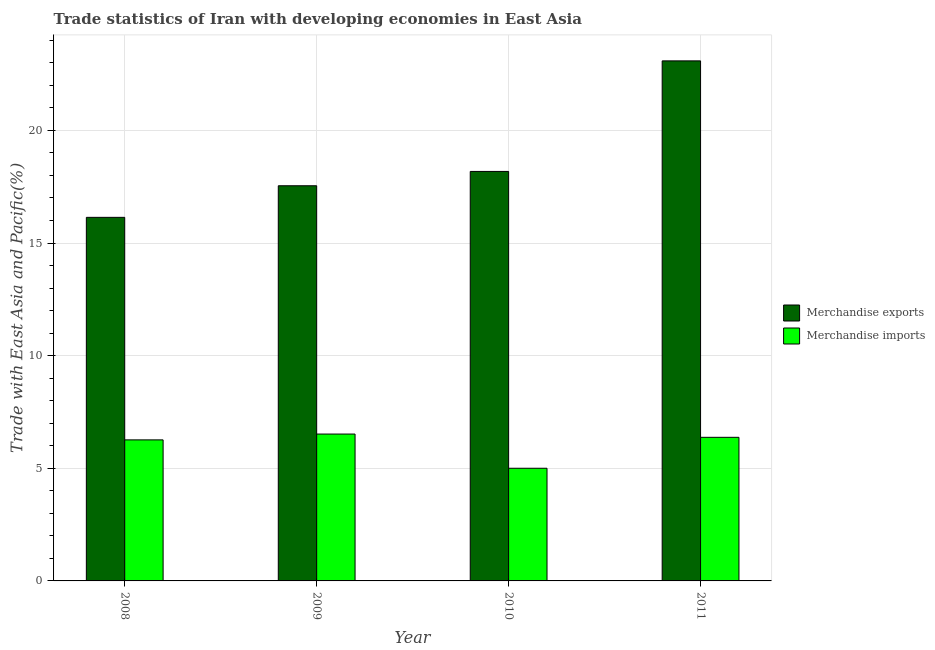Are the number of bars on each tick of the X-axis equal?
Offer a terse response. Yes. How many bars are there on the 1st tick from the left?
Keep it short and to the point. 2. In how many cases, is the number of bars for a given year not equal to the number of legend labels?
Offer a terse response. 0. What is the merchandise imports in 2009?
Offer a very short reply. 6.52. Across all years, what is the maximum merchandise exports?
Your answer should be compact. 23.09. Across all years, what is the minimum merchandise imports?
Provide a short and direct response. 5. In which year was the merchandise exports maximum?
Offer a very short reply. 2011. What is the total merchandise exports in the graph?
Offer a terse response. 74.94. What is the difference between the merchandise imports in 2009 and that in 2011?
Your answer should be very brief. 0.15. What is the difference between the merchandise exports in 2011 and the merchandise imports in 2009?
Your response must be concise. 5.54. What is the average merchandise imports per year?
Your answer should be compact. 6.04. In the year 2008, what is the difference between the merchandise exports and merchandise imports?
Offer a very short reply. 0. In how many years, is the merchandise exports greater than 2 %?
Provide a succinct answer. 4. What is the ratio of the merchandise imports in 2008 to that in 2009?
Make the answer very short. 0.96. What is the difference between the highest and the second highest merchandise imports?
Keep it short and to the point. 0.15. What is the difference between the highest and the lowest merchandise exports?
Your answer should be very brief. 6.95. Is the sum of the merchandise imports in 2010 and 2011 greater than the maximum merchandise exports across all years?
Ensure brevity in your answer.  Yes. What does the 2nd bar from the right in 2009 represents?
Provide a short and direct response. Merchandise exports. What is the difference between two consecutive major ticks on the Y-axis?
Your answer should be compact. 5. Are the values on the major ticks of Y-axis written in scientific E-notation?
Your answer should be compact. No. Where does the legend appear in the graph?
Offer a very short reply. Center right. How are the legend labels stacked?
Your answer should be compact. Vertical. What is the title of the graph?
Keep it short and to the point. Trade statistics of Iran with developing economies in East Asia. What is the label or title of the Y-axis?
Keep it short and to the point. Trade with East Asia and Pacific(%). What is the Trade with East Asia and Pacific(%) of Merchandise exports in 2008?
Make the answer very short. 16.14. What is the Trade with East Asia and Pacific(%) of Merchandise imports in 2008?
Your response must be concise. 6.26. What is the Trade with East Asia and Pacific(%) of Merchandise exports in 2009?
Give a very brief answer. 17.54. What is the Trade with East Asia and Pacific(%) of Merchandise imports in 2009?
Offer a very short reply. 6.52. What is the Trade with East Asia and Pacific(%) in Merchandise exports in 2010?
Your answer should be compact. 18.18. What is the Trade with East Asia and Pacific(%) of Merchandise imports in 2010?
Keep it short and to the point. 5. What is the Trade with East Asia and Pacific(%) of Merchandise exports in 2011?
Your answer should be compact. 23.09. What is the Trade with East Asia and Pacific(%) in Merchandise imports in 2011?
Provide a succinct answer. 6.37. Across all years, what is the maximum Trade with East Asia and Pacific(%) in Merchandise exports?
Give a very brief answer. 23.09. Across all years, what is the maximum Trade with East Asia and Pacific(%) in Merchandise imports?
Provide a succinct answer. 6.52. Across all years, what is the minimum Trade with East Asia and Pacific(%) in Merchandise exports?
Your answer should be very brief. 16.14. Across all years, what is the minimum Trade with East Asia and Pacific(%) of Merchandise imports?
Give a very brief answer. 5. What is the total Trade with East Asia and Pacific(%) of Merchandise exports in the graph?
Provide a succinct answer. 74.94. What is the total Trade with East Asia and Pacific(%) of Merchandise imports in the graph?
Offer a very short reply. 24.16. What is the difference between the Trade with East Asia and Pacific(%) in Merchandise exports in 2008 and that in 2009?
Provide a short and direct response. -1.4. What is the difference between the Trade with East Asia and Pacific(%) in Merchandise imports in 2008 and that in 2009?
Keep it short and to the point. -0.26. What is the difference between the Trade with East Asia and Pacific(%) in Merchandise exports in 2008 and that in 2010?
Your response must be concise. -2.04. What is the difference between the Trade with East Asia and Pacific(%) of Merchandise imports in 2008 and that in 2010?
Provide a succinct answer. 1.26. What is the difference between the Trade with East Asia and Pacific(%) in Merchandise exports in 2008 and that in 2011?
Your answer should be very brief. -6.95. What is the difference between the Trade with East Asia and Pacific(%) of Merchandise imports in 2008 and that in 2011?
Your response must be concise. -0.11. What is the difference between the Trade with East Asia and Pacific(%) of Merchandise exports in 2009 and that in 2010?
Make the answer very short. -0.64. What is the difference between the Trade with East Asia and Pacific(%) of Merchandise imports in 2009 and that in 2010?
Ensure brevity in your answer.  1.52. What is the difference between the Trade with East Asia and Pacific(%) in Merchandise exports in 2009 and that in 2011?
Ensure brevity in your answer.  -5.54. What is the difference between the Trade with East Asia and Pacific(%) in Merchandise imports in 2009 and that in 2011?
Your answer should be very brief. 0.15. What is the difference between the Trade with East Asia and Pacific(%) of Merchandise exports in 2010 and that in 2011?
Give a very brief answer. -4.91. What is the difference between the Trade with East Asia and Pacific(%) of Merchandise imports in 2010 and that in 2011?
Give a very brief answer. -1.37. What is the difference between the Trade with East Asia and Pacific(%) of Merchandise exports in 2008 and the Trade with East Asia and Pacific(%) of Merchandise imports in 2009?
Ensure brevity in your answer.  9.62. What is the difference between the Trade with East Asia and Pacific(%) in Merchandise exports in 2008 and the Trade with East Asia and Pacific(%) in Merchandise imports in 2010?
Your answer should be very brief. 11.14. What is the difference between the Trade with East Asia and Pacific(%) in Merchandise exports in 2008 and the Trade with East Asia and Pacific(%) in Merchandise imports in 2011?
Offer a terse response. 9.76. What is the difference between the Trade with East Asia and Pacific(%) in Merchandise exports in 2009 and the Trade with East Asia and Pacific(%) in Merchandise imports in 2010?
Provide a succinct answer. 12.54. What is the difference between the Trade with East Asia and Pacific(%) of Merchandise exports in 2009 and the Trade with East Asia and Pacific(%) of Merchandise imports in 2011?
Offer a very short reply. 11.17. What is the difference between the Trade with East Asia and Pacific(%) in Merchandise exports in 2010 and the Trade with East Asia and Pacific(%) in Merchandise imports in 2011?
Make the answer very short. 11.8. What is the average Trade with East Asia and Pacific(%) in Merchandise exports per year?
Ensure brevity in your answer.  18.74. What is the average Trade with East Asia and Pacific(%) in Merchandise imports per year?
Offer a very short reply. 6.04. In the year 2008, what is the difference between the Trade with East Asia and Pacific(%) of Merchandise exports and Trade with East Asia and Pacific(%) of Merchandise imports?
Your answer should be very brief. 9.88. In the year 2009, what is the difference between the Trade with East Asia and Pacific(%) in Merchandise exports and Trade with East Asia and Pacific(%) in Merchandise imports?
Your answer should be very brief. 11.02. In the year 2010, what is the difference between the Trade with East Asia and Pacific(%) of Merchandise exports and Trade with East Asia and Pacific(%) of Merchandise imports?
Give a very brief answer. 13.18. In the year 2011, what is the difference between the Trade with East Asia and Pacific(%) in Merchandise exports and Trade with East Asia and Pacific(%) in Merchandise imports?
Keep it short and to the point. 16.71. What is the ratio of the Trade with East Asia and Pacific(%) in Merchandise exports in 2008 to that in 2009?
Your answer should be compact. 0.92. What is the ratio of the Trade with East Asia and Pacific(%) in Merchandise imports in 2008 to that in 2009?
Your response must be concise. 0.96. What is the ratio of the Trade with East Asia and Pacific(%) in Merchandise exports in 2008 to that in 2010?
Ensure brevity in your answer.  0.89. What is the ratio of the Trade with East Asia and Pacific(%) in Merchandise imports in 2008 to that in 2010?
Offer a very short reply. 1.25. What is the ratio of the Trade with East Asia and Pacific(%) of Merchandise exports in 2008 to that in 2011?
Offer a very short reply. 0.7. What is the ratio of the Trade with East Asia and Pacific(%) in Merchandise imports in 2008 to that in 2011?
Keep it short and to the point. 0.98. What is the ratio of the Trade with East Asia and Pacific(%) of Merchandise imports in 2009 to that in 2010?
Make the answer very short. 1.3. What is the ratio of the Trade with East Asia and Pacific(%) in Merchandise exports in 2009 to that in 2011?
Ensure brevity in your answer.  0.76. What is the ratio of the Trade with East Asia and Pacific(%) of Merchandise imports in 2009 to that in 2011?
Give a very brief answer. 1.02. What is the ratio of the Trade with East Asia and Pacific(%) in Merchandise exports in 2010 to that in 2011?
Make the answer very short. 0.79. What is the ratio of the Trade with East Asia and Pacific(%) in Merchandise imports in 2010 to that in 2011?
Keep it short and to the point. 0.78. What is the difference between the highest and the second highest Trade with East Asia and Pacific(%) of Merchandise exports?
Your answer should be very brief. 4.91. What is the difference between the highest and the second highest Trade with East Asia and Pacific(%) in Merchandise imports?
Provide a short and direct response. 0.15. What is the difference between the highest and the lowest Trade with East Asia and Pacific(%) in Merchandise exports?
Ensure brevity in your answer.  6.95. What is the difference between the highest and the lowest Trade with East Asia and Pacific(%) in Merchandise imports?
Provide a succinct answer. 1.52. 